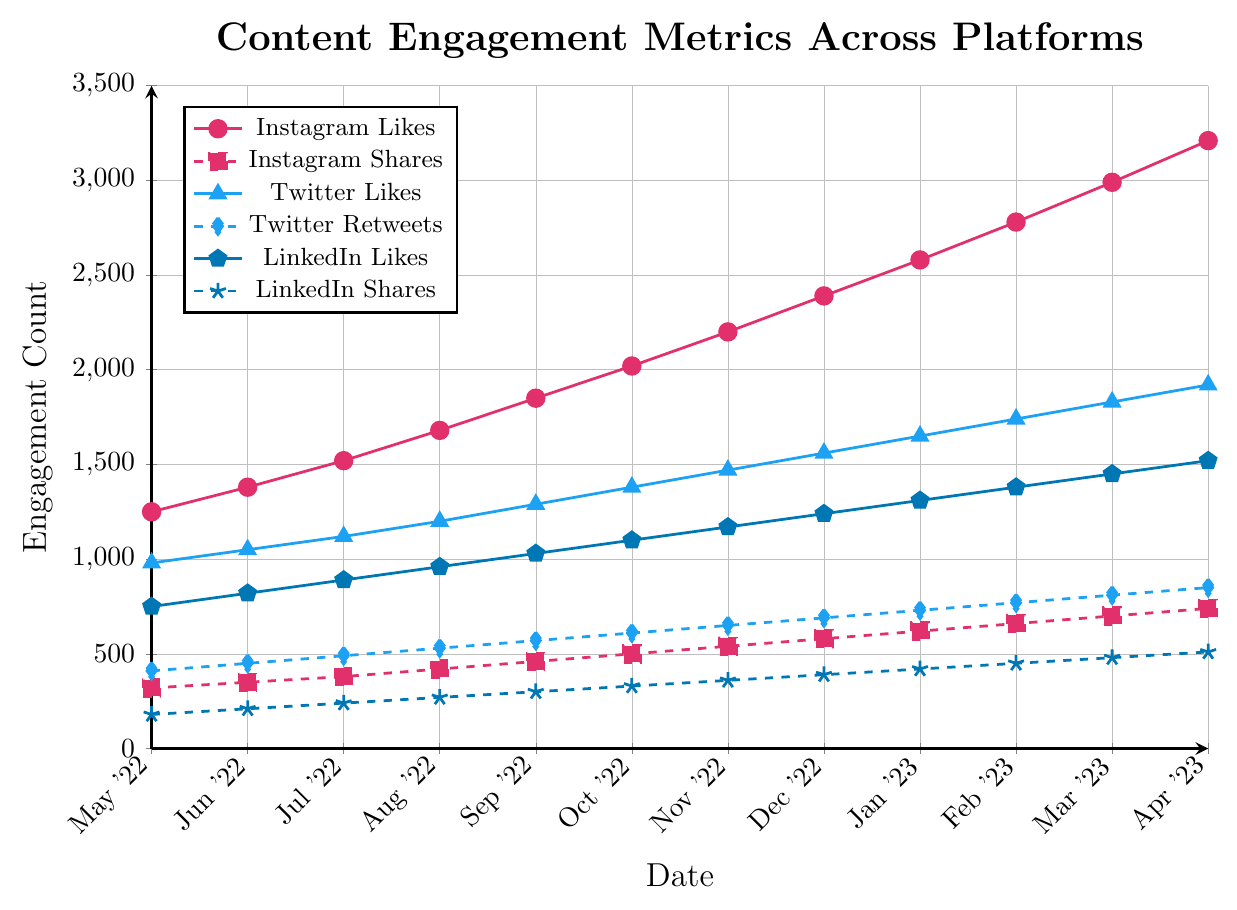Which platform had the highest number of likes in April 2023? By looking at the graph, the top line corresponds to Instagram Likes. In April 2023, Instagram had the highest likes count reaching 3210.
Answer: Instagram How many more shares did LinkedIn have in April 2023 compared to August 2022? Check the LinkedIn Shares line at both points: in April 2023, LinkedIn Shares were 510, and in August 2022, they were 270. Subtracting 270 from 510 gives 240.
Answer: 240 Which platform had the greatest increase in likes from May 2022 to April 2023? Calculate the difference for each platform:
- Instagram: 3210 - 1250 = 1960
- Twitter: 1920 - 980 = 940
- LinkedIn: 1520 - 750 = 770
Instagram had the greatest increase in likes with a difference of 1960.
Answer: Instagram On which month did Twitter Retweets first surpass 600? Locate the Twitter Retweets line and note the values each month. The first time Twitter Retweets surpassed 600 was in October 2022 with a value of 610.
Answer: October 2022 What is the average number of LinkedIn Comments from May 2022 to April 2023? Sum the LinkedIn Comments counts and divide by 12:
(95 + 110 + 125 + 140 + 155 + 170 + 185 + 200 + 215 + 230 + 245 + 260) / 12 = 2030 / 12 ≈ 169.2
Answer: 169.2 Which platform had the steadiest growth in shares over the 12-month period? Look for consistency in the trend lines of shares:
- Instagram Shares: steady upward trend
- LinkedIn Shares: steady upward trend
- Twitter Retweets: steady upward trend
All three platforms show a steady upward trend, but LinkedIn Shares have the most consistent growth with smaller increments.
Answer: LinkedIn In February 2023, how many total likes did all platforms combined accumulate? Sum the likes from each platform in February 2023:
- Instagram Likes: 2780
- Twitter Likes: 1740
- LinkedIn Likes: 1380
Total Likes = 2780 + 1740 + 1380 = 5900
Answer: 5900 Which platform showed the least increase in comments from July 2022 to April 2023? Calculate the comment increases for each platform:
- Instagram Comments: 510 - 240 = 270
- Twitter Replies: 370 - 190 = 180
- LinkedIn Comments: 260 - 125 = 135
LinkedIn showed the least increase with 135 more comments.
Answer: LinkedIn 